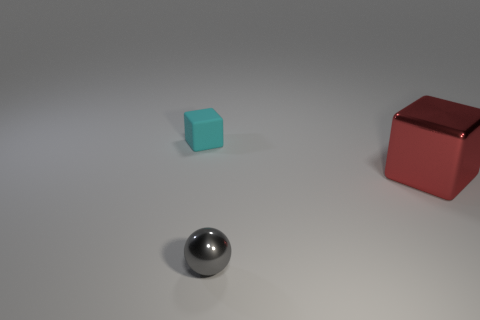There is a block on the right side of the shiny thing in front of the cube in front of the rubber thing; what is it made of?
Provide a succinct answer. Metal. What number of yellow objects are either big matte blocks or big metal blocks?
Keep it short and to the point. 0. There is a cube in front of the object on the left side of the small thing right of the matte thing; how big is it?
Keep it short and to the point. Large. What size is the other cyan thing that is the same shape as the big object?
Ensure brevity in your answer.  Small. What number of tiny objects are either cubes or red blocks?
Keep it short and to the point. 1. Is the material of the block that is to the right of the tiny metallic ball the same as the block left of the gray sphere?
Make the answer very short. No. What is the material of the small thing in front of the big red thing?
Provide a short and direct response. Metal. How many shiny things are either tiny gray blocks or cubes?
Your answer should be compact. 1. What color is the small object to the right of the cube on the left side of the metal sphere?
Your answer should be compact. Gray. Is the gray ball made of the same material as the cube in front of the matte cube?
Keep it short and to the point. Yes. 